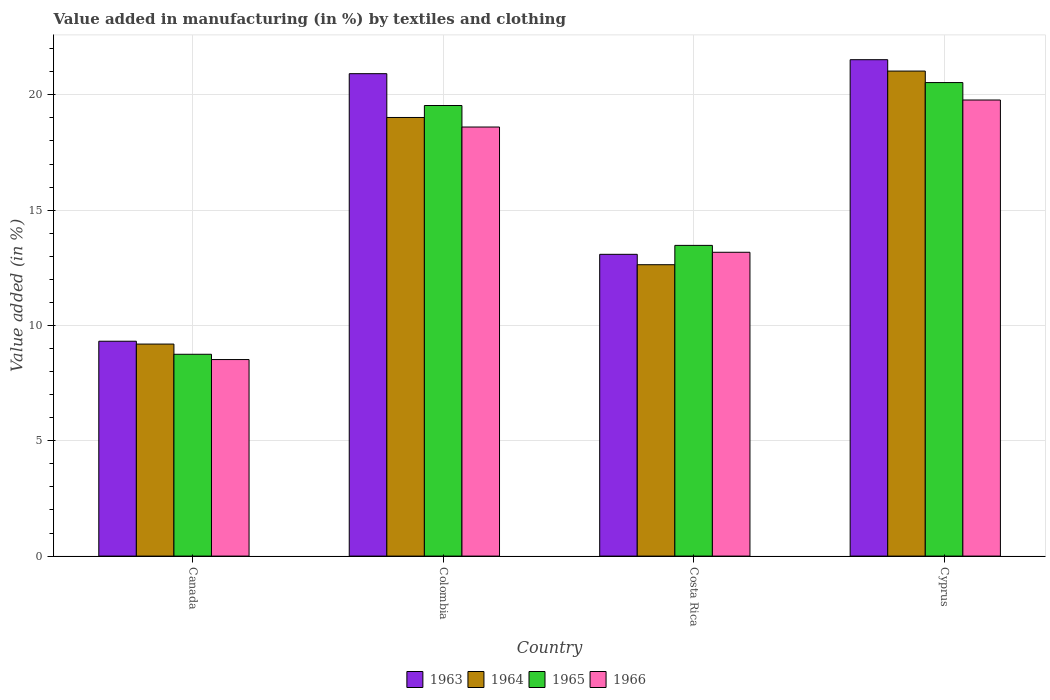Are the number of bars per tick equal to the number of legend labels?
Offer a very short reply. Yes. Are the number of bars on each tick of the X-axis equal?
Offer a very short reply. Yes. How many bars are there on the 2nd tick from the right?
Offer a terse response. 4. What is the label of the 4th group of bars from the left?
Ensure brevity in your answer.  Cyprus. What is the percentage of value added in manufacturing by textiles and clothing in 1964 in Costa Rica?
Keep it short and to the point. 12.63. Across all countries, what is the maximum percentage of value added in manufacturing by textiles and clothing in 1966?
Your answer should be compact. 19.78. Across all countries, what is the minimum percentage of value added in manufacturing by textiles and clothing in 1966?
Provide a succinct answer. 8.52. In which country was the percentage of value added in manufacturing by textiles and clothing in 1963 maximum?
Provide a succinct answer. Cyprus. What is the total percentage of value added in manufacturing by textiles and clothing in 1965 in the graph?
Make the answer very short. 62.29. What is the difference between the percentage of value added in manufacturing by textiles and clothing in 1965 in Colombia and that in Cyprus?
Make the answer very short. -0.99. What is the difference between the percentage of value added in manufacturing by textiles and clothing in 1966 in Colombia and the percentage of value added in manufacturing by textiles and clothing in 1963 in Canada?
Your response must be concise. 9.29. What is the average percentage of value added in manufacturing by textiles and clothing in 1966 per country?
Give a very brief answer. 15.02. What is the difference between the percentage of value added in manufacturing by textiles and clothing of/in 1965 and percentage of value added in manufacturing by textiles and clothing of/in 1964 in Costa Rica?
Your answer should be very brief. 0.84. In how many countries, is the percentage of value added in manufacturing by textiles and clothing in 1966 greater than 11 %?
Ensure brevity in your answer.  3. What is the ratio of the percentage of value added in manufacturing by textiles and clothing in 1963 in Colombia to that in Costa Rica?
Keep it short and to the point. 1.6. What is the difference between the highest and the second highest percentage of value added in manufacturing by textiles and clothing in 1964?
Your answer should be very brief. 6.38. What is the difference between the highest and the lowest percentage of value added in manufacturing by textiles and clothing in 1964?
Provide a succinct answer. 11.84. In how many countries, is the percentage of value added in manufacturing by textiles and clothing in 1963 greater than the average percentage of value added in manufacturing by textiles and clothing in 1963 taken over all countries?
Give a very brief answer. 2. What does the 3rd bar from the left in Cyprus represents?
Make the answer very short. 1965. What does the 2nd bar from the right in Colombia represents?
Provide a short and direct response. 1965. What is the difference between two consecutive major ticks on the Y-axis?
Ensure brevity in your answer.  5. Are the values on the major ticks of Y-axis written in scientific E-notation?
Your answer should be compact. No. Does the graph contain any zero values?
Keep it short and to the point. No. Where does the legend appear in the graph?
Your response must be concise. Bottom center. How many legend labels are there?
Keep it short and to the point. 4. What is the title of the graph?
Your response must be concise. Value added in manufacturing (in %) by textiles and clothing. Does "1965" appear as one of the legend labels in the graph?
Ensure brevity in your answer.  Yes. What is the label or title of the Y-axis?
Provide a succinct answer. Value added (in %). What is the Value added (in %) in 1963 in Canada?
Give a very brief answer. 9.32. What is the Value added (in %) of 1964 in Canada?
Your response must be concise. 9.19. What is the Value added (in %) of 1965 in Canada?
Your answer should be very brief. 8.75. What is the Value added (in %) in 1966 in Canada?
Your response must be concise. 8.52. What is the Value added (in %) of 1963 in Colombia?
Offer a terse response. 20.92. What is the Value added (in %) of 1964 in Colombia?
Make the answer very short. 19.02. What is the Value added (in %) of 1965 in Colombia?
Offer a terse response. 19.54. What is the Value added (in %) in 1966 in Colombia?
Provide a succinct answer. 18.6. What is the Value added (in %) in 1963 in Costa Rica?
Keep it short and to the point. 13.08. What is the Value added (in %) in 1964 in Costa Rica?
Keep it short and to the point. 12.63. What is the Value added (in %) in 1965 in Costa Rica?
Your answer should be compact. 13.47. What is the Value added (in %) in 1966 in Costa Rica?
Make the answer very short. 13.17. What is the Value added (in %) in 1963 in Cyprus?
Make the answer very short. 21.52. What is the Value added (in %) in 1964 in Cyprus?
Your response must be concise. 21.03. What is the Value added (in %) of 1965 in Cyprus?
Ensure brevity in your answer.  20.53. What is the Value added (in %) in 1966 in Cyprus?
Give a very brief answer. 19.78. Across all countries, what is the maximum Value added (in %) in 1963?
Give a very brief answer. 21.52. Across all countries, what is the maximum Value added (in %) of 1964?
Keep it short and to the point. 21.03. Across all countries, what is the maximum Value added (in %) in 1965?
Keep it short and to the point. 20.53. Across all countries, what is the maximum Value added (in %) in 1966?
Offer a very short reply. 19.78. Across all countries, what is the minimum Value added (in %) of 1963?
Your response must be concise. 9.32. Across all countries, what is the minimum Value added (in %) in 1964?
Provide a succinct answer. 9.19. Across all countries, what is the minimum Value added (in %) in 1965?
Your response must be concise. 8.75. Across all countries, what is the minimum Value added (in %) in 1966?
Ensure brevity in your answer.  8.52. What is the total Value added (in %) of 1963 in the graph?
Your response must be concise. 64.84. What is the total Value added (in %) of 1964 in the graph?
Ensure brevity in your answer.  61.88. What is the total Value added (in %) of 1965 in the graph?
Offer a terse response. 62.29. What is the total Value added (in %) of 1966 in the graph?
Your answer should be compact. 60.08. What is the difference between the Value added (in %) of 1963 in Canada and that in Colombia?
Provide a succinct answer. -11.6. What is the difference between the Value added (in %) in 1964 in Canada and that in Colombia?
Keep it short and to the point. -9.82. What is the difference between the Value added (in %) of 1965 in Canada and that in Colombia?
Keep it short and to the point. -10.79. What is the difference between the Value added (in %) of 1966 in Canada and that in Colombia?
Offer a terse response. -10.08. What is the difference between the Value added (in %) of 1963 in Canada and that in Costa Rica?
Ensure brevity in your answer.  -3.77. What is the difference between the Value added (in %) of 1964 in Canada and that in Costa Rica?
Give a very brief answer. -3.44. What is the difference between the Value added (in %) in 1965 in Canada and that in Costa Rica?
Your answer should be compact. -4.72. What is the difference between the Value added (in %) in 1966 in Canada and that in Costa Rica?
Keep it short and to the point. -4.65. What is the difference between the Value added (in %) of 1963 in Canada and that in Cyprus?
Provide a short and direct response. -12.21. What is the difference between the Value added (in %) of 1964 in Canada and that in Cyprus?
Ensure brevity in your answer.  -11.84. What is the difference between the Value added (in %) of 1965 in Canada and that in Cyprus?
Your answer should be very brief. -11.78. What is the difference between the Value added (in %) in 1966 in Canada and that in Cyprus?
Your answer should be compact. -11.25. What is the difference between the Value added (in %) in 1963 in Colombia and that in Costa Rica?
Provide a short and direct response. 7.83. What is the difference between the Value added (in %) in 1964 in Colombia and that in Costa Rica?
Make the answer very short. 6.38. What is the difference between the Value added (in %) in 1965 in Colombia and that in Costa Rica?
Provide a short and direct response. 6.06. What is the difference between the Value added (in %) of 1966 in Colombia and that in Costa Rica?
Make the answer very short. 5.43. What is the difference between the Value added (in %) of 1963 in Colombia and that in Cyprus?
Give a very brief answer. -0.61. What is the difference between the Value added (in %) in 1964 in Colombia and that in Cyprus?
Make the answer very short. -2.01. What is the difference between the Value added (in %) of 1965 in Colombia and that in Cyprus?
Offer a very short reply. -0.99. What is the difference between the Value added (in %) in 1966 in Colombia and that in Cyprus?
Offer a terse response. -1.17. What is the difference between the Value added (in %) in 1963 in Costa Rica and that in Cyprus?
Give a very brief answer. -8.44. What is the difference between the Value added (in %) of 1964 in Costa Rica and that in Cyprus?
Give a very brief answer. -8.4. What is the difference between the Value added (in %) of 1965 in Costa Rica and that in Cyprus?
Provide a succinct answer. -7.06. What is the difference between the Value added (in %) of 1966 in Costa Rica and that in Cyprus?
Keep it short and to the point. -6.6. What is the difference between the Value added (in %) of 1963 in Canada and the Value added (in %) of 1964 in Colombia?
Your answer should be compact. -9.7. What is the difference between the Value added (in %) in 1963 in Canada and the Value added (in %) in 1965 in Colombia?
Give a very brief answer. -10.22. What is the difference between the Value added (in %) in 1963 in Canada and the Value added (in %) in 1966 in Colombia?
Your answer should be compact. -9.29. What is the difference between the Value added (in %) in 1964 in Canada and the Value added (in %) in 1965 in Colombia?
Provide a succinct answer. -10.34. What is the difference between the Value added (in %) in 1964 in Canada and the Value added (in %) in 1966 in Colombia?
Your response must be concise. -9.41. What is the difference between the Value added (in %) in 1965 in Canada and the Value added (in %) in 1966 in Colombia?
Your answer should be very brief. -9.85. What is the difference between the Value added (in %) in 1963 in Canada and the Value added (in %) in 1964 in Costa Rica?
Offer a very short reply. -3.32. What is the difference between the Value added (in %) of 1963 in Canada and the Value added (in %) of 1965 in Costa Rica?
Your response must be concise. -4.16. What is the difference between the Value added (in %) of 1963 in Canada and the Value added (in %) of 1966 in Costa Rica?
Keep it short and to the point. -3.86. What is the difference between the Value added (in %) of 1964 in Canada and the Value added (in %) of 1965 in Costa Rica?
Give a very brief answer. -4.28. What is the difference between the Value added (in %) of 1964 in Canada and the Value added (in %) of 1966 in Costa Rica?
Offer a terse response. -3.98. What is the difference between the Value added (in %) in 1965 in Canada and the Value added (in %) in 1966 in Costa Rica?
Ensure brevity in your answer.  -4.42. What is the difference between the Value added (in %) in 1963 in Canada and the Value added (in %) in 1964 in Cyprus?
Your response must be concise. -11.71. What is the difference between the Value added (in %) in 1963 in Canada and the Value added (in %) in 1965 in Cyprus?
Make the answer very short. -11.21. What is the difference between the Value added (in %) of 1963 in Canada and the Value added (in %) of 1966 in Cyprus?
Make the answer very short. -10.46. What is the difference between the Value added (in %) of 1964 in Canada and the Value added (in %) of 1965 in Cyprus?
Offer a very short reply. -11.34. What is the difference between the Value added (in %) of 1964 in Canada and the Value added (in %) of 1966 in Cyprus?
Keep it short and to the point. -10.58. What is the difference between the Value added (in %) in 1965 in Canada and the Value added (in %) in 1966 in Cyprus?
Offer a very short reply. -11.02. What is the difference between the Value added (in %) of 1963 in Colombia and the Value added (in %) of 1964 in Costa Rica?
Offer a terse response. 8.28. What is the difference between the Value added (in %) of 1963 in Colombia and the Value added (in %) of 1965 in Costa Rica?
Make the answer very short. 7.44. What is the difference between the Value added (in %) in 1963 in Colombia and the Value added (in %) in 1966 in Costa Rica?
Your answer should be very brief. 7.74. What is the difference between the Value added (in %) in 1964 in Colombia and the Value added (in %) in 1965 in Costa Rica?
Keep it short and to the point. 5.55. What is the difference between the Value added (in %) in 1964 in Colombia and the Value added (in %) in 1966 in Costa Rica?
Offer a very short reply. 5.84. What is the difference between the Value added (in %) of 1965 in Colombia and the Value added (in %) of 1966 in Costa Rica?
Make the answer very short. 6.36. What is the difference between the Value added (in %) of 1963 in Colombia and the Value added (in %) of 1964 in Cyprus?
Your answer should be very brief. -0.11. What is the difference between the Value added (in %) in 1963 in Colombia and the Value added (in %) in 1965 in Cyprus?
Provide a succinct answer. 0.39. What is the difference between the Value added (in %) of 1963 in Colombia and the Value added (in %) of 1966 in Cyprus?
Provide a succinct answer. 1.14. What is the difference between the Value added (in %) in 1964 in Colombia and the Value added (in %) in 1965 in Cyprus?
Your answer should be compact. -1.51. What is the difference between the Value added (in %) of 1964 in Colombia and the Value added (in %) of 1966 in Cyprus?
Your response must be concise. -0.76. What is the difference between the Value added (in %) of 1965 in Colombia and the Value added (in %) of 1966 in Cyprus?
Provide a short and direct response. -0.24. What is the difference between the Value added (in %) of 1963 in Costa Rica and the Value added (in %) of 1964 in Cyprus?
Your response must be concise. -7.95. What is the difference between the Value added (in %) in 1963 in Costa Rica and the Value added (in %) in 1965 in Cyprus?
Offer a terse response. -7.45. What is the difference between the Value added (in %) in 1963 in Costa Rica and the Value added (in %) in 1966 in Cyprus?
Your response must be concise. -6.69. What is the difference between the Value added (in %) in 1964 in Costa Rica and the Value added (in %) in 1965 in Cyprus?
Ensure brevity in your answer.  -7.9. What is the difference between the Value added (in %) of 1964 in Costa Rica and the Value added (in %) of 1966 in Cyprus?
Give a very brief answer. -7.14. What is the difference between the Value added (in %) in 1965 in Costa Rica and the Value added (in %) in 1966 in Cyprus?
Ensure brevity in your answer.  -6.3. What is the average Value added (in %) of 1963 per country?
Your answer should be compact. 16.21. What is the average Value added (in %) of 1964 per country?
Provide a succinct answer. 15.47. What is the average Value added (in %) of 1965 per country?
Give a very brief answer. 15.57. What is the average Value added (in %) in 1966 per country?
Provide a short and direct response. 15.02. What is the difference between the Value added (in %) in 1963 and Value added (in %) in 1964 in Canada?
Offer a very short reply. 0.12. What is the difference between the Value added (in %) of 1963 and Value added (in %) of 1965 in Canada?
Make the answer very short. 0.57. What is the difference between the Value added (in %) in 1963 and Value added (in %) in 1966 in Canada?
Keep it short and to the point. 0.8. What is the difference between the Value added (in %) of 1964 and Value added (in %) of 1965 in Canada?
Give a very brief answer. 0.44. What is the difference between the Value added (in %) in 1964 and Value added (in %) in 1966 in Canada?
Your answer should be very brief. 0.67. What is the difference between the Value added (in %) of 1965 and Value added (in %) of 1966 in Canada?
Keep it short and to the point. 0.23. What is the difference between the Value added (in %) of 1963 and Value added (in %) of 1964 in Colombia?
Your answer should be very brief. 1.9. What is the difference between the Value added (in %) of 1963 and Value added (in %) of 1965 in Colombia?
Ensure brevity in your answer.  1.38. What is the difference between the Value added (in %) in 1963 and Value added (in %) in 1966 in Colombia?
Give a very brief answer. 2.31. What is the difference between the Value added (in %) of 1964 and Value added (in %) of 1965 in Colombia?
Give a very brief answer. -0.52. What is the difference between the Value added (in %) of 1964 and Value added (in %) of 1966 in Colombia?
Offer a terse response. 0.41. What is the difference between the Value added (in %) in 1965 and Value added (in %) in 1966 in Colombia?
Ensure brevity in your answer.  0.93. What is the difference between the Value added (in %) in 1963 and Value added (in %) in 1964 in Costa Rica?
Provide a succinct answer. 0.45. What is the difference between the Value added (in %) in 1963 and Value added (in %) in 1965 in Costa Rica?
Provide a succinct answer. -0.39. What is the difference between the Value added (in %) of 1963 and Value added (in %) of 1966 in Costa Rica?
Provide a succinct answer. -0.09. What is the difference between the Value added (in %) of 1964 and Value added (in %) of 1965 in Costa Rica?
Your answer should be compact. -0.84. What is the difference between the Value added (in %) in 1964 and Value added (in %) in 1966 in Costa Rica?
Provide a succinct answer. -0.54. What is the difference between the Value added (in %) in 1965 and Value added (in %) in 1966 in Costa Rica?
Offer a very short reply. 0.3. What is the difference between the Value added (in %) of 1963 and Value added (in %) of 1964 in Cyprus?
Your answer should be very brief. 0.49. What is the difference between the Value added (in %) of 1963 and Value added (in %) of 1966 in Cyprus?
Offer a very short reply. 1.75. What is the difference between the Value added (in %) of 1964 and Value added (in %) of 1965 in Cyprus?
Your response must be concise. 0.5. What is the difference between the Value added (in %) of 1964 and Value added (in %) of 1966 in Cyprus?
Offer a very short reply. 1.25. What is the difference between the Value added (in %) of 1965 and Value added (in %) of 1966 in Cyprus?
Keep it short and to the point. 0.76. What is the ratio of the Value added (in %) in 1963 in Canada to that in Colombia?
Provide a succinct answer. 0.45. What is the ratio of the Value added (in %) in 1964 in Canada to that in Colombia?
Your response must be concise. 0.48. What is the ratio of the Value added (in %) of 1965 in Canada to that in Colombia?
Your answer should be compact. 0.45. What is the ratio of the Value added (in %) of 1966 in Canada to that in Colombia?
Your response must be concise. 0.46. What is the ratio of the Value added (in %) of 1963 in Canada to that in Costa Rica?
Offer a terse response. 0.71. What is the ratio of the Value added (in %) in 1964 in Canada to that in Costa Rica?
Your response must be concise. 0.73. What is the ratio of the Value added (in %) in 1965 in Canada to that in Costa Rica?
Your response must be concise. 0.65. What is the ratio of the Value added (in %) in 1966 in Canada to that in Costa Rica?
Your response must be concise. 0.65. What is the ratio of the Value added (in %) in 1963 in Canada to that in Cyprus?
Keep it short and to the point. 0.43. What is the ratio of the Value added (in %) of 1964 in Canada to that in Cyprus?
Give a very brief answer. 0.44. What is the ratio of the Value added (in %) in 1965 in Canada to that in Cyprus?
Your response must be concise. 0.43. What is the ratio of the Value added (in %) in 1966 in Canada to that in Cyprus?
Your answer should be compact. 0.43. What is the ratio of the Value added (in %) in 1963 in Colombia to that in Costa Rica?
Keep it short and to the point. 1.6. What is the ratio of the Value added (in %) in 1964 in Colombia to that in Costa Rica?
Offer a very short reply. 1.51. What is the ratio of the Value added (in %) of 1965 in Colombia to that in Costa Rica?
Offer a very short reply. 1.45. What is the ratio of the Value added (in %) in 1966 in Colombia to that in Costa Rica?
Offer a very short reply. 1.41. What is the ratio of the Value added (in %) in 1963 in Colombia to that in Cyprus?
Make the answer very short. 0.97. What is the ratio of the Value added (in %) of 1964 in Colombia to that in Cyprus?
Provide a succinct answer. 0.9. What is the ratio of the Value added (in %) of 1965 in Colombia to that in Cyprus?
Offer a very short reply. 0.95. What is the ratio of the Value added (in %) of 1966 in Colombia to that in Cyprus?
Ensure brevity in your answer.  0.94. What is the ratio of the Value added (in %) in 1963 in Costa Rica to that in Cyprus?
Provide a short and direct response. 0.61. What is the ratio of the Value added (in %) of 1964 in Costa Rica to that in Cyprus?
Your answer should be compact. 0.6. What is the ratio of the Value added (in %) of 1965 in Costa Rica to that in Cyprus?
Make the answer very short. 0.66. What is the ratio of the Value added (in %) of 1966 in Costa Rica to that in Cyprus?
Offer a terse response. 0.67. What is the difference between the highest and the second highest Value added (in %) of 1963?
Keep it short and to the point. 0.61. What is the difference between the highest and the second highest Value added (in %) in 1964?
Keep it short and to the point. 2.01. What is the difference between the highest and the second highest Value added (in %) in 1965?
Provide a short and direct response. 0.99. What is the difference between the highest and the second highest Value added (in %) of 1966?
Provide a short and direct response. 1.17. What is the difference between the highest and the lowest Value added (in %) of 1963?
Provide a short and direct response. 12.21. What is the difference between the highest and the lowest Value added (in %) of 1964?
Make the answer very short. 11.84. What is the difference between the highest and the lowest Value added (in %) of 1965?
Offer a terse response. 11.78. What is the difference between the highest and the lowest Value added (in %) in 1966?
Offer a terse response. 11.25. 